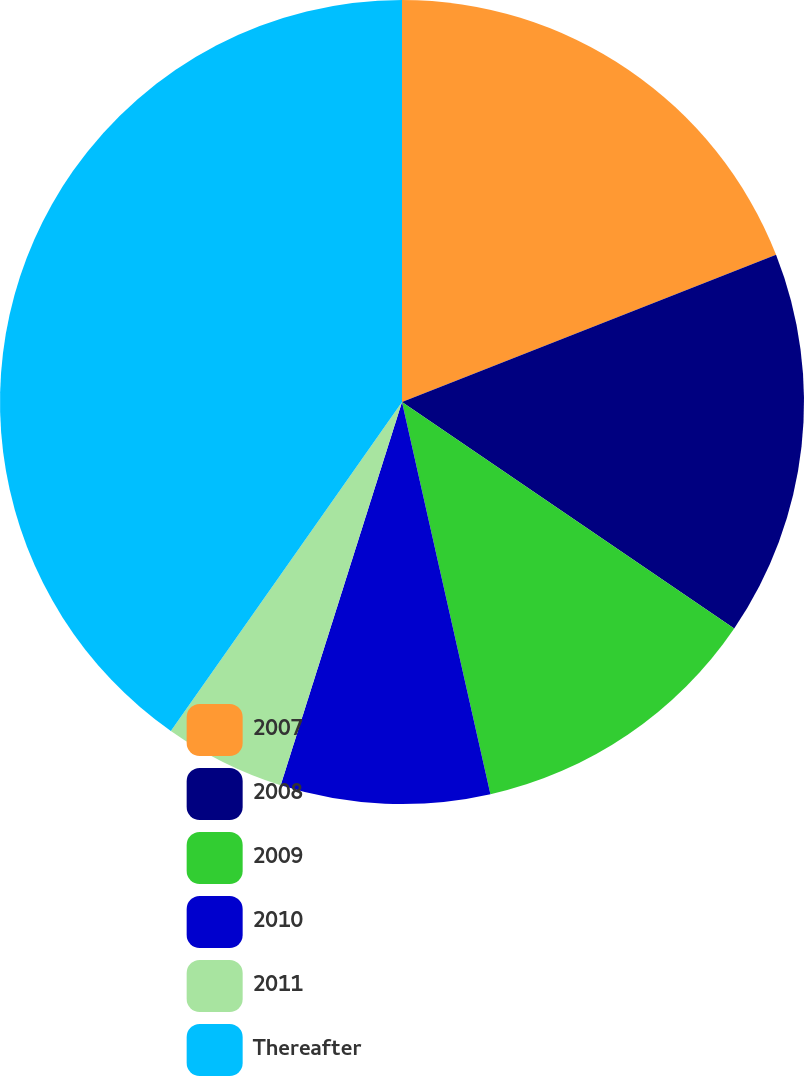Convert chart. <chart><loc_0><loc_0><loc_500><loc_500><pie_chart><fcel>2007<fcel>2008<fcel>2009<fcel>2010<fcel>2011<fcel>Thereafter<nl><fcel>19.03%<fcel>15.49%<fcel>11.95%<fcel>8.41%<fcel>4.87%<fcel>40.25%<nl></chart> 